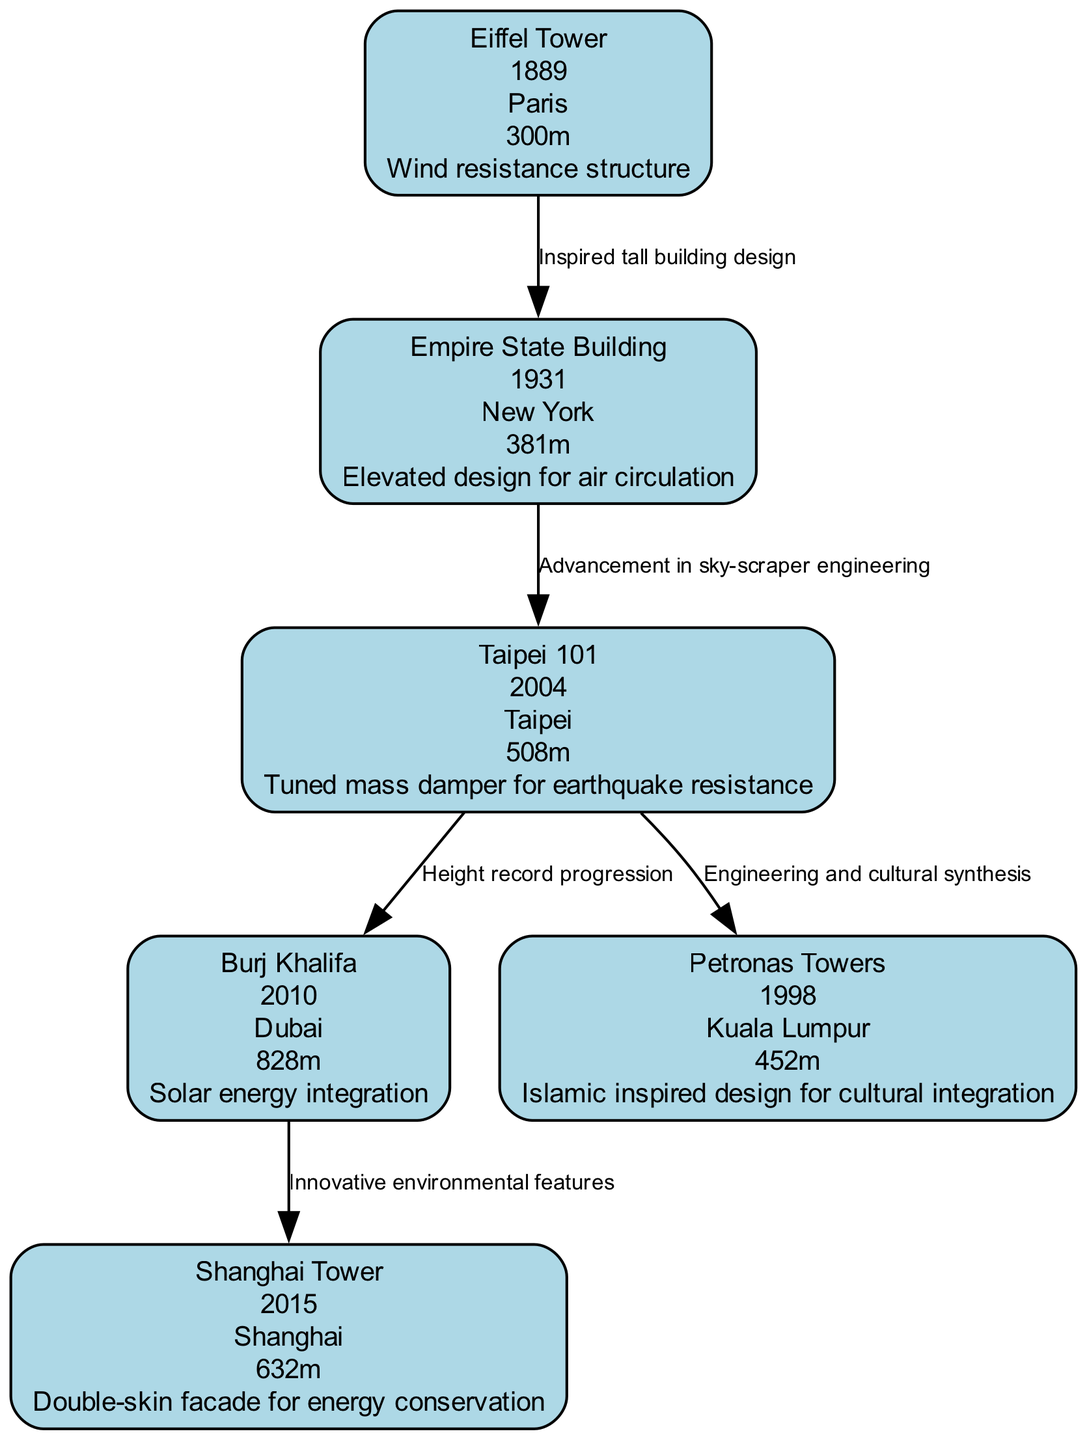What is the height of the Burj Khalifa? The node for Burj Khalifa indicates its height as 828 meters.
Answer: 828 meters Which skyscraper features a tuned mass damper for earthquake resistance? The Taipei 101 node specifies its environmental adaptation as a tuned mass damper for earthquake resistance.
Answer: Taipei 101 How many skyscrapers are shown in the ancestry of major skyscrapers? There are six nodes representing distinct skyscrapers in the diagram.
Answer: 6 What relationship exists between the Empire State Building and Taipei 101? According to the connections, the Empire State Building is linked to Taipei 101 through the relationship "Advancement in sky-scraper engineering."
Answer: Advancement in sky-scraper engineering Which skyscraper has the environmental adaptation of solar energy integration? The Burj Khalifa node indicates that it incorporates solar energy integration as its environmental adaptation.
Answer: Burj Khalifa What is the city of the Petronas Towers? The Petronas Towers node lists Kuala Lumpur as its city.
Answer: Kuala Lumpur Which structure is known for its Islamic inspired design? The environmental adaptation listed for the Petronas Towers specifies its Islamic inspired design.
Answer: Petronas Towers What year was the Shanghai Tower completed? The Shanghai Tower node indicates it was built in the year 2015.
Answer: 2015 Which skyscraper is the tallest in the diagram? The Burj Khalifa is identified as the tallest skyscraper, measuring 828 meters.
Answer: Burj Khalifa 